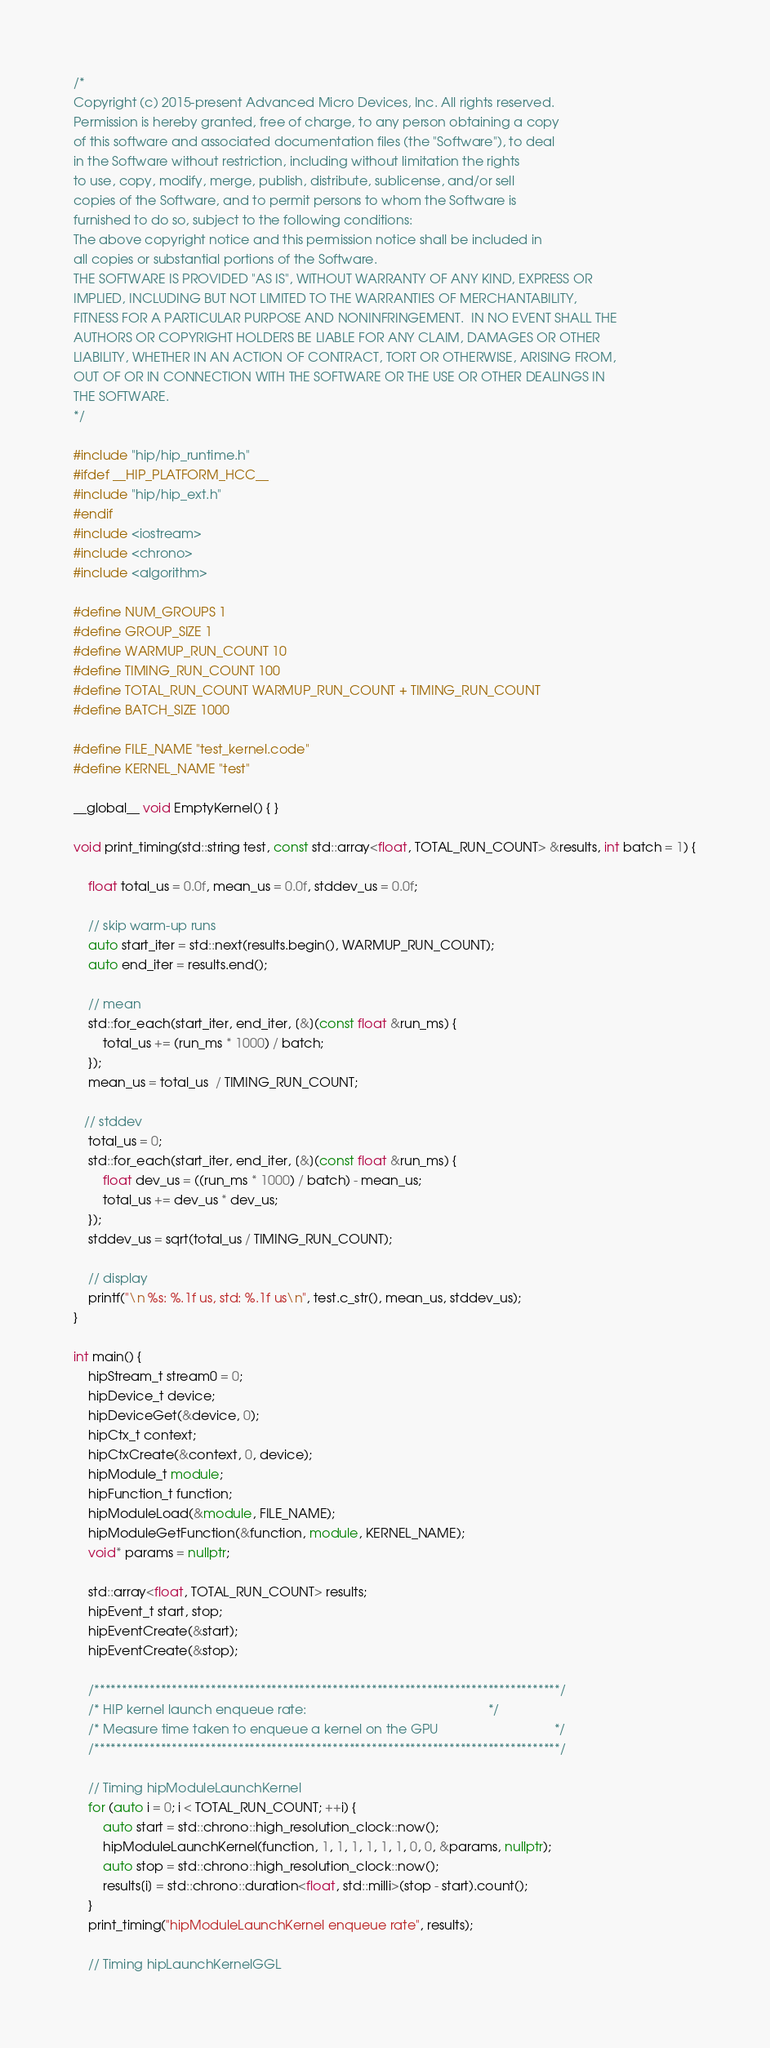<code> <loc_0><loc_0><loc_500><loc_500><_C++_>/*
Copyright (c) 2015-present Advanced Micro Devices, Inc. All rights reserved.
Permission is hereby granted, free of charge, to any person obtaining a copy
of this software and associated documentation files (the "Software"), to deal
in the Software without restriction, including without limitation the rights
to use, copy, modify, merge, publish, distribute, sublicense, and/or sell
copies of the Software, and to permit persons to whom the Software is
furnished to do so, subject to the following conditions:
The above copyright notice and this permission notice shall be included in
all copies or substantial portions of the Software.
THE SOFTWARE IS PROVIDED "AS IS", WITHOUT WARRANTY OF ANY KIND, EXPRESS OR
IMPLIED, INCLUDING BUT NOT LIMITED TO THE WARRANTIES OF MERCHANTABILITY,
FITNESS FOR A PARTICULAR PURPOSE AND NONINFRINGEMENT.  IN NO EVENT SHALL THE
AUTHORS OR COPYRIGHT HOLDERS BE LIABLE FOR ANY CLAIM, DAMAGES OR OTHER
LIABILITY, WHETHER IN AN ACTION OF CONTRACT, TORT OR OTHERWISE, ARISING FROM,
OUT OF OR IN CONNECTION WITH THE SOFTWARE OR THE USE OR OTHER DEALINGS IN
THE SOFTWARE.
*/

#include "hip/hip_runtime.h"
#ifdef __HIP_PLATFORM_HCC__
#include "hip/hip_ext.h"
#endif
#include <iostream>
#include <chrono>
#include <algorithm>

#define NUM_GROUPS 1
#define GROUP_SIZE 1
#define WARMUP_RUN_COUNT 10
#define TIMING_RUN_COUNT 100
#define TOTAL_RUN_COUNT WARMUP_RUN_COUNT + TIMING_RUN_COUNT
#define BATCH_SIZE 1000

#define FILE_NAME "test_kernel.code"
#define KERNEL_NAME "test"

__global__ void EmptyKernel() { }

void print_timing(std::string test, const std::array<float, TOTAL_RUN_COUNT> &results, int batch = 1) {
    
    float total_us = 0.0f, mean_us = 0.0f, stddev_us = 0.0f;
    
    // skip warm-up runs
    auto start_iter = std::next(results.begin(), WARMUP_RUN_COUNT);
    auto end_iter = results.end();

    // mean
    std::for_each(start_iter, end_iter, [&](const float &run_ms) {
        total_us += (run_ms * 1000) / batch;
    });   
    mean_us = total_us  / TIMING_RUN_COUNT;

   // stddev
    total_us = 0;
    std::for_each(start_iter, end_iter, [&](const float &run_ms) {
        float dev_us = ((run_ms * 1000) / batch) - mean_us;
        total_us += dev_us * dev_us;
    });
    stddev_us = sqrt(total_us / TIMING_RUN_COUNT);

    // display
    printf("\n %s: %.1f us, std: %.1f us\n", test.c_str(), mean_us, stddev_us);
}

int main() {   
    hipStream_t stream0 = 0;
    hipDevice_t device;
    hipDeviceGet(&device, 0);
    hipCtx_t context;     
    hipCtxCreate(&context, 0, device); 
    hipModule_t module;
    hipFunction_t function;
    hipModuleLoad(&module, FILE_NAME);
    hipModuleGetFunction(&function, module, KERNEL_NAME);
    void* params = nullptr;
    
    std::array<float, TOTAL_RUN_COUNT> results;
    hipEvent_t start, stop;
    hipEventCreate(&start);
    hipEventCreate(&stop);

    /************************************************************************************/
    /* HIP kernel launch enqueue rate:                                                  */
    /* Measure time taken to enqueue a kernel on the GPU                                */
    /************************************************************************************/ 

    // Timing hipModuleLaunchKernel
    for (auto i = 0; i < TOTAL_RUN_COUNT; ++i) {
        auto start = std::chrono::high_resolution_clock::now();
        hipModuleLaunchKernel(function, 1, 1, 1, 1, 1, 1, 0, 0, &params, nullptr);
        auto stop = std::chrono::high_resolution_clock::now();
        results[i] = std::chrono::duration<float, std::milli>(stop - start).count();
    }
    print_timing("hipModuleLaunchKernel enqueue rate", results);

    // Timing hipLaunchKernelGGL</code> 